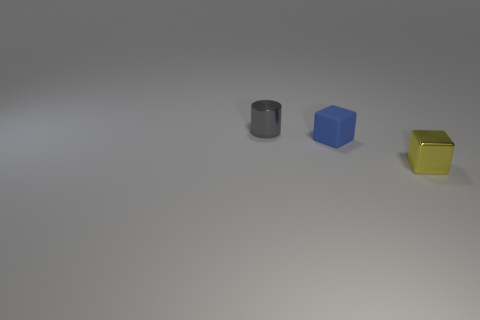Subtract 1 blocks. How many blocks are left? 1 Subtract all blocks. How many objects are left? 1 Add 1 cyan rubber spheres. How many objects exist? 4 Subtract all blue cubes. How many cubes are left? 1 Subtract 0 red cylinders. How many objects are left? 3 Subtract all cyan cubes. Subtract all yellow cylinders. How many cubes are left? 2 Subtract all gray cylinders. How many red cubes are left? 0 Subtract all purple balls. Subtract all small yellow things. How many objects are left? 2 Add 3 tiny rubber blocks. How many tiny rubber blocks are left? 4 Add 3 yellow blocks. How many yellow blocks exist? 4 